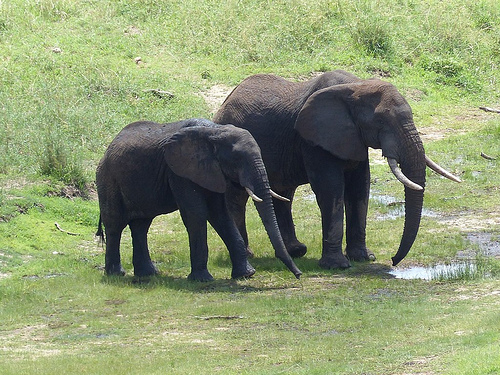What animal is in front of the hill? The animal in front of the hill is an elephant. 